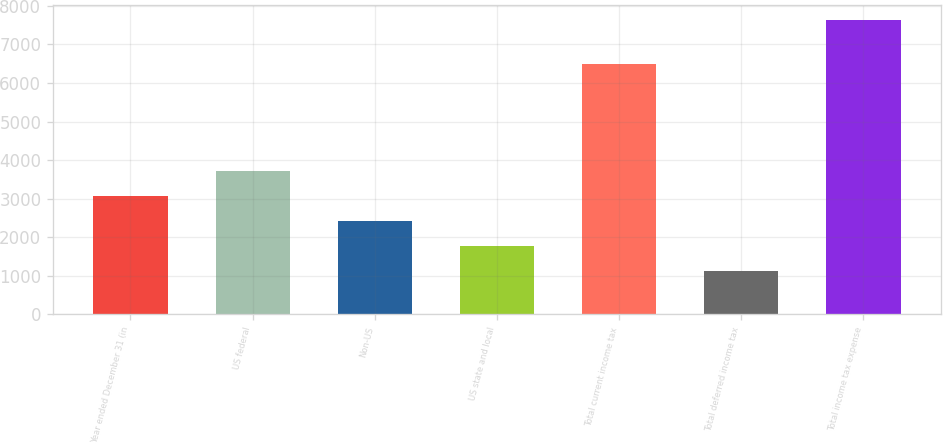Convert chart. <chart><loc_0><loc_0><loc_500><loc_500><bar_chart><fcel>Year ended December 31 (in<fcel>US federal<fcel>Non-US<fcel>US state and local<fcel>Total current income tax<fcel>Total deferred income tax<fcel>Total income tax expense<nl><fcel>3080.9<fcel>3731.2<fcel>2430.6<fcel>1780.3<fcel>6503<fcel>1130<fcel>7633<nl></chart> 